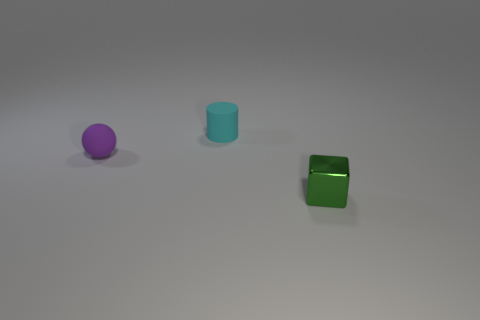Subtract 1 blocks. How many blocks are left? 0 Add 1 large cyan matte balls. How many objects exist? 4 Subtract all balls. How many objects are left? 2 Subtract all blue cylinders. Subtract all gray cubes. How many cylinders are left? 1 Add 2 shiny blocks. How many shiny blocks are left? 3 Add 2 yellow balls. How many yellow balls exist? 2 Subtract 0 blue blocks. How many objects are left? 3 Subtract all rubber spheres. Subtract all big blue metal cylinders. How many objects are left? 2 